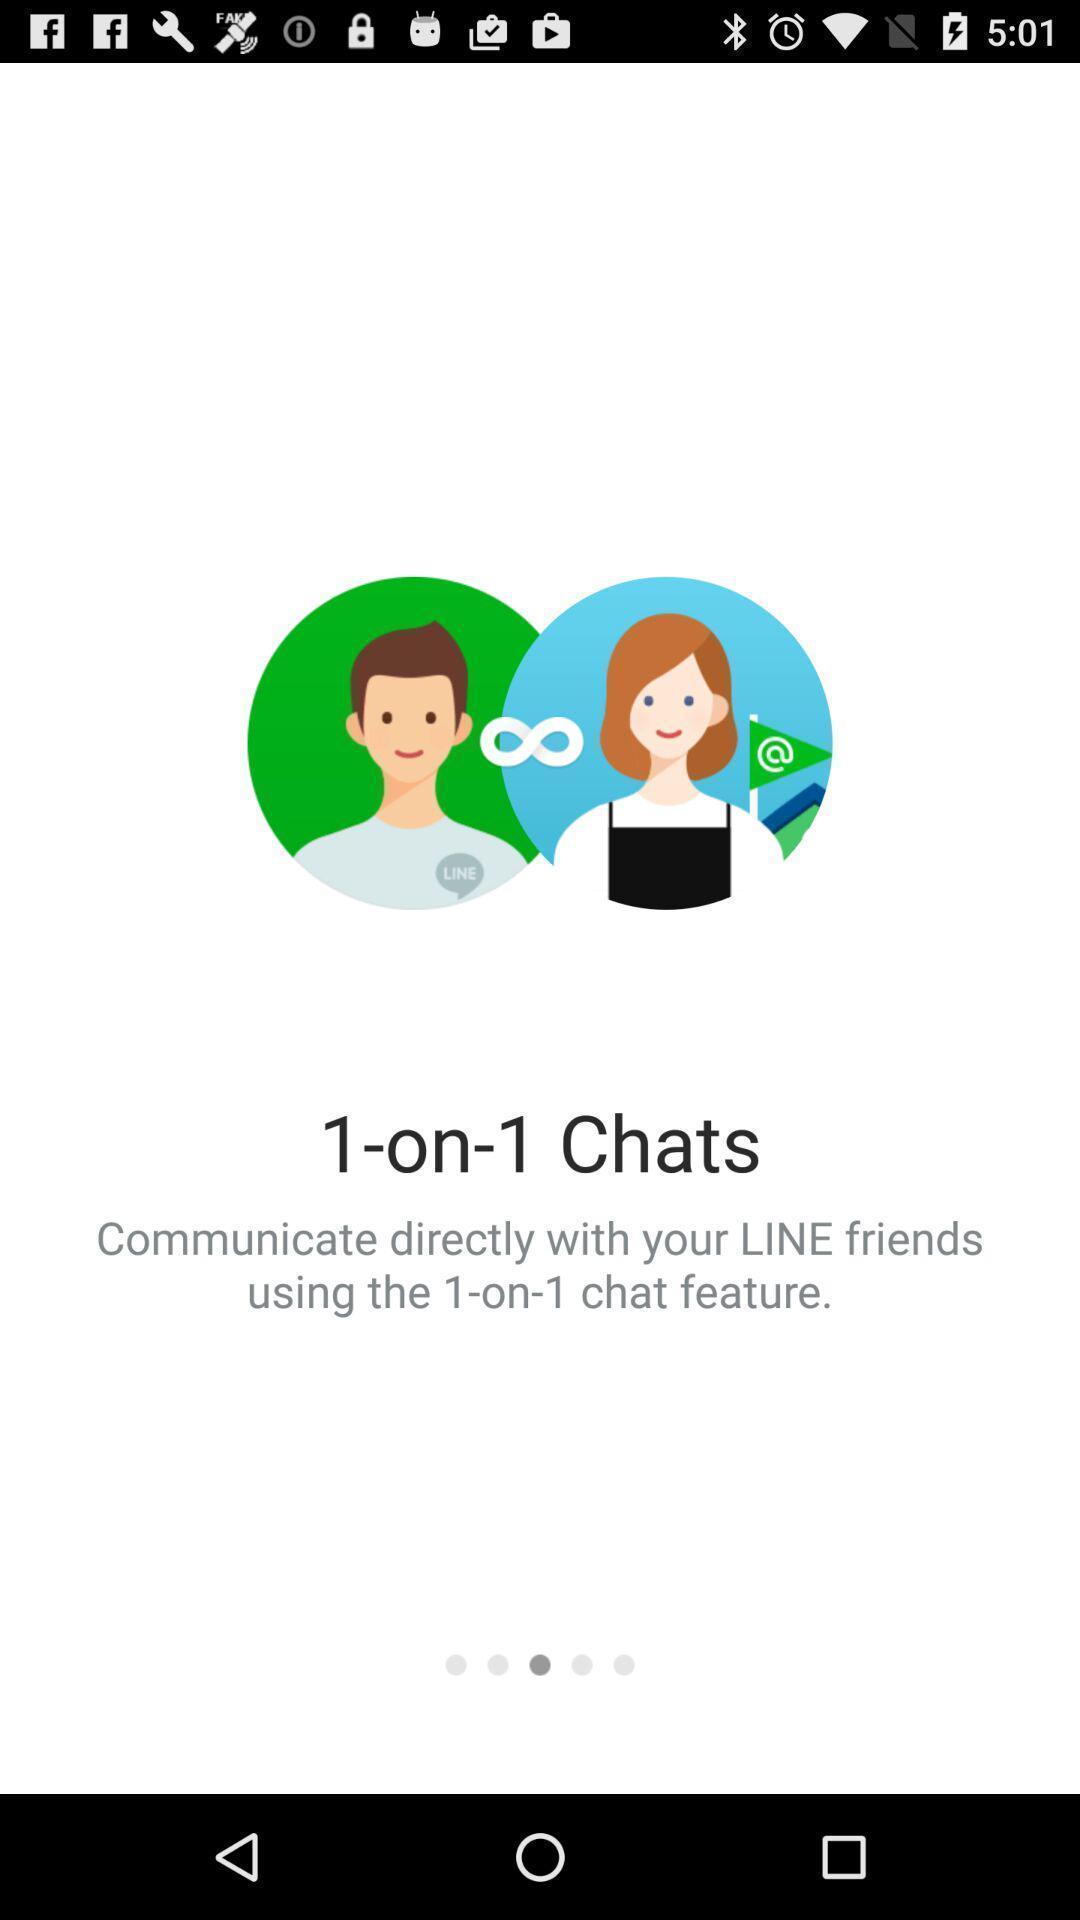Describe this image in words. Screen showing page. 